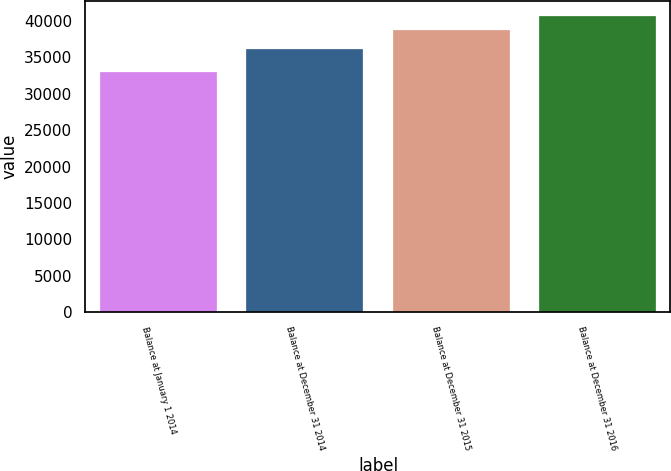<chart> <loc_0><loc_0><loc_500><loc_500><bar_chart><fcel>Balance at January 1 2014<fcel>Balance at December 31 2014<fcel>Balance at December 31 2015<fcel>Balance at December 31 2016<nl><fcel>32964<fcel>36180<fcel>38756<fcel>40714<nl></chart> 